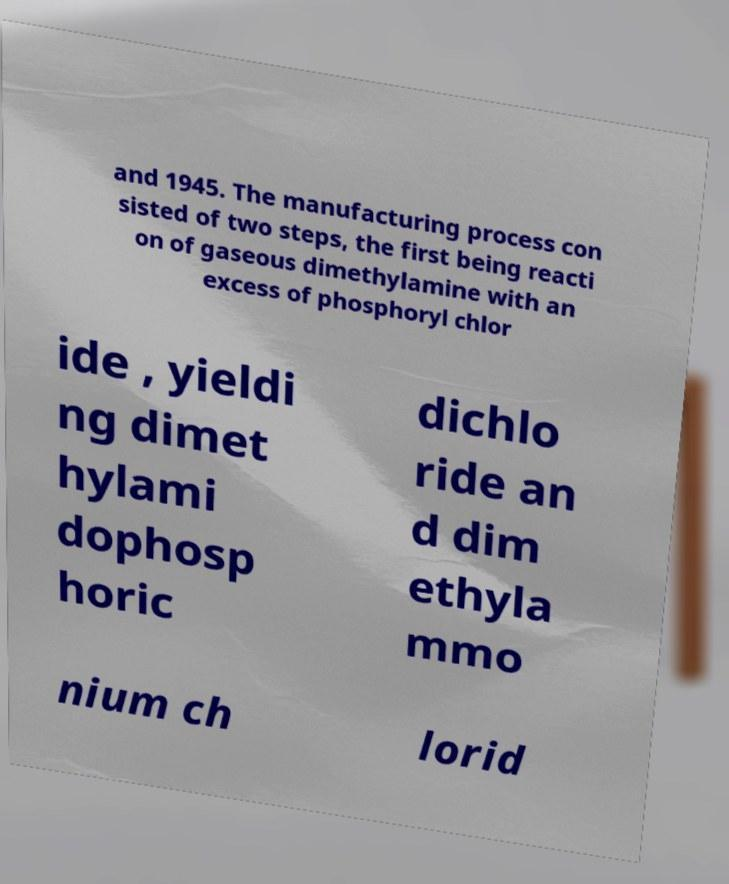Could you extract and type out the text from this image? and 1945. The manufacturing process con sisted of two steps, the first being reacti on of gaseous dimethylamine with an excess of phosphoryl chlor ide , yieldi ng dimet hylami dophosp horic dichlo ride an d dim ethyla mmo nium ch lorid 